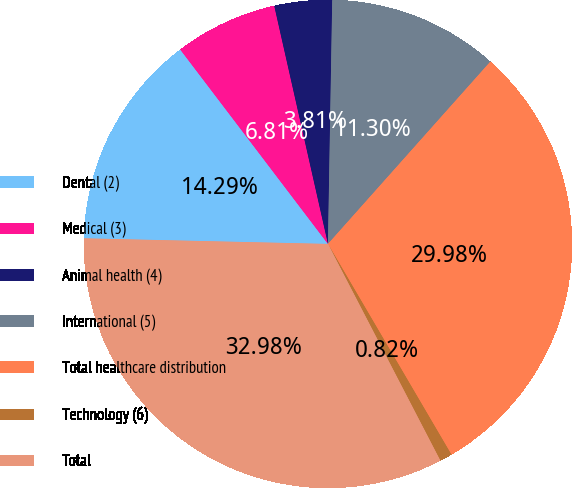Convert chart. <chart><loc_0><loc_0><loc_500><loc_500><pie_chart><fcel>Dental (2)<fcel>Medical (3)<fcel>Animal health (4)<fcel>International (5)<fcel>Total healthcare distribution<fcel>Technology (6)<fcel>Total<nl><fcel>14.29%<fcel>6.81%<fcel>3.81%<fcel>11.3%<fcel>29.98%<fcel>0.82%<fcel>32.98%<nl></chart> 